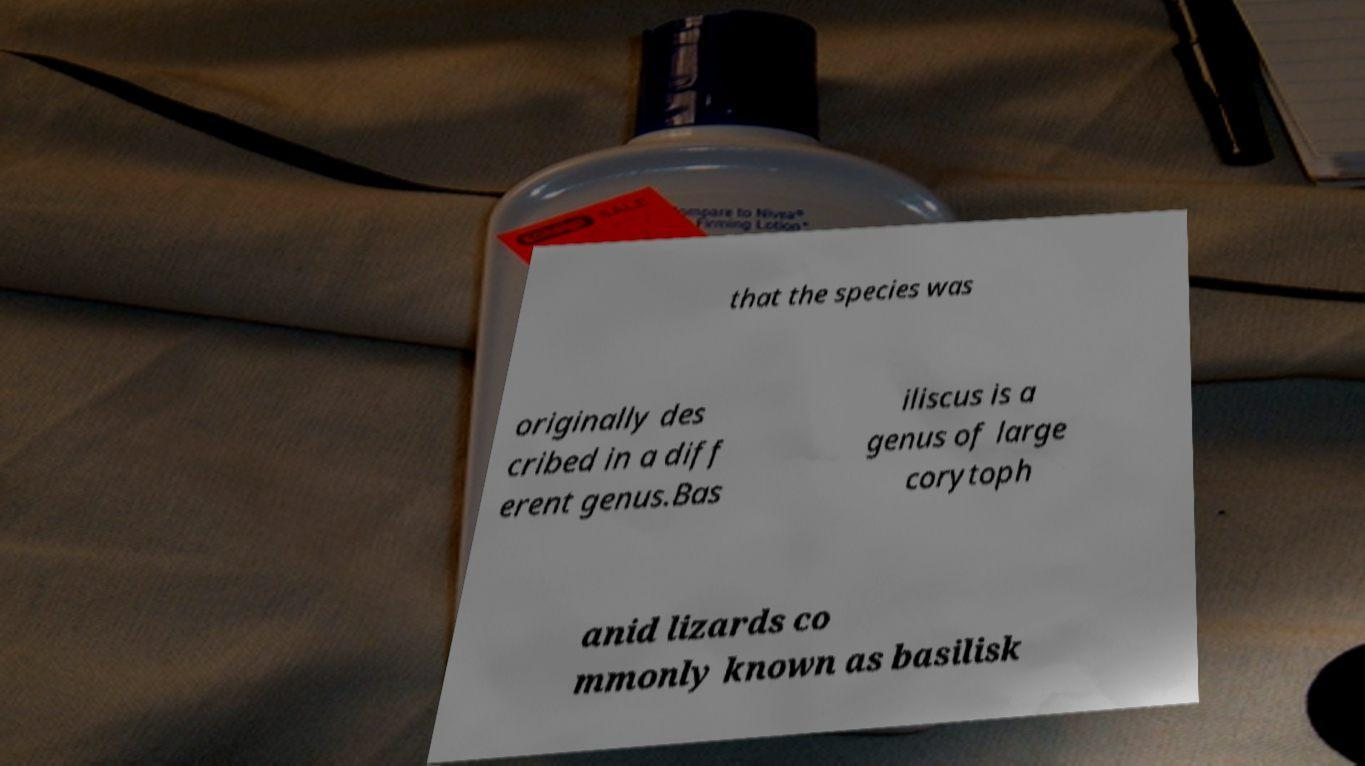I need the written content from this picture converted into text. Can you do that? that the species was originally des cribed in a diff erent genus.Bas iliscus is a genus of large corytoph anid lizards co mmonly known as basilisk 